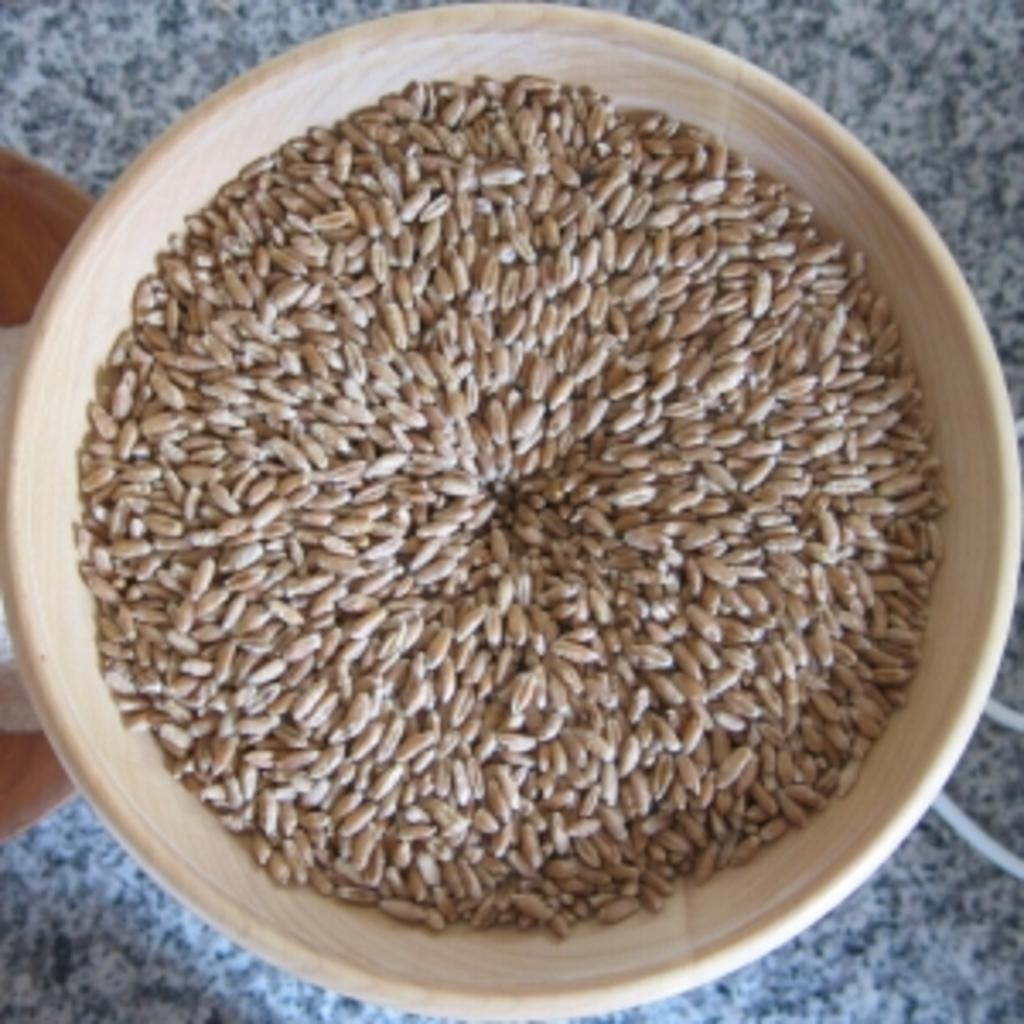What is in the bowl that is visible in the image? There is wheat in a bowl in the image. Where is the bowl located in the image? The bowl is on a platform in the image. Can you describe the object on the left side of the image? The object on the left side of the image is truncated, meaning it is partially cut off or not fully visible. What type of mint plant can be seen growing on the platform in the image? There is no mint plant visible in the image; it features wheat in a bowl on a platform. 